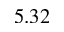<formula> <loc_0><loc_0><loc_500><loc_500>5 . 3 2</formula> 